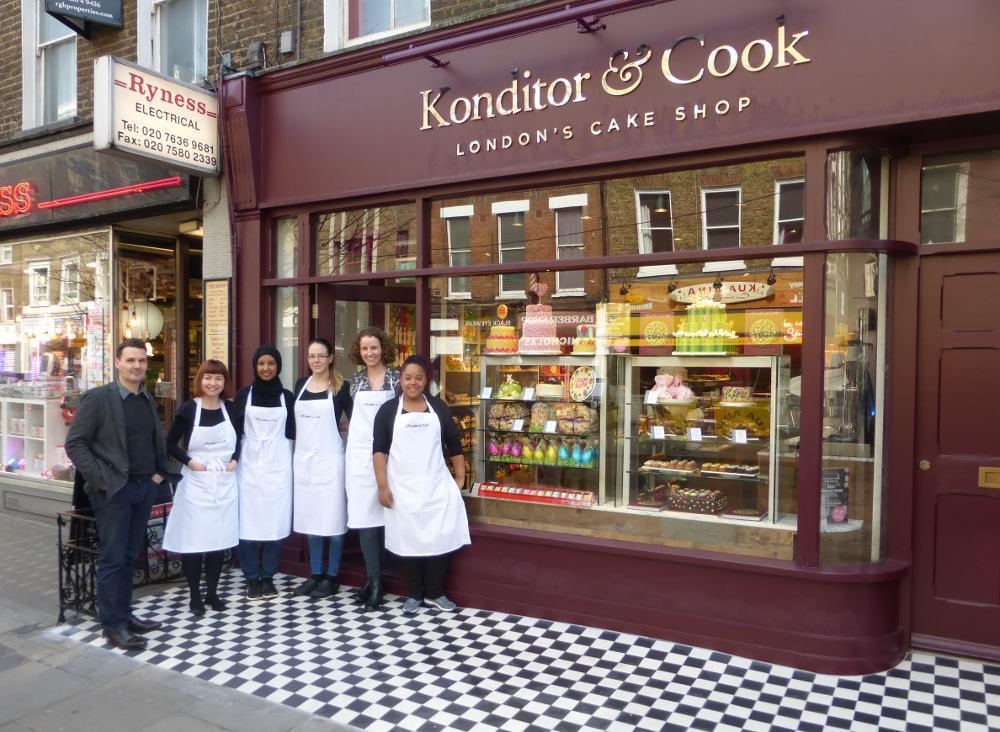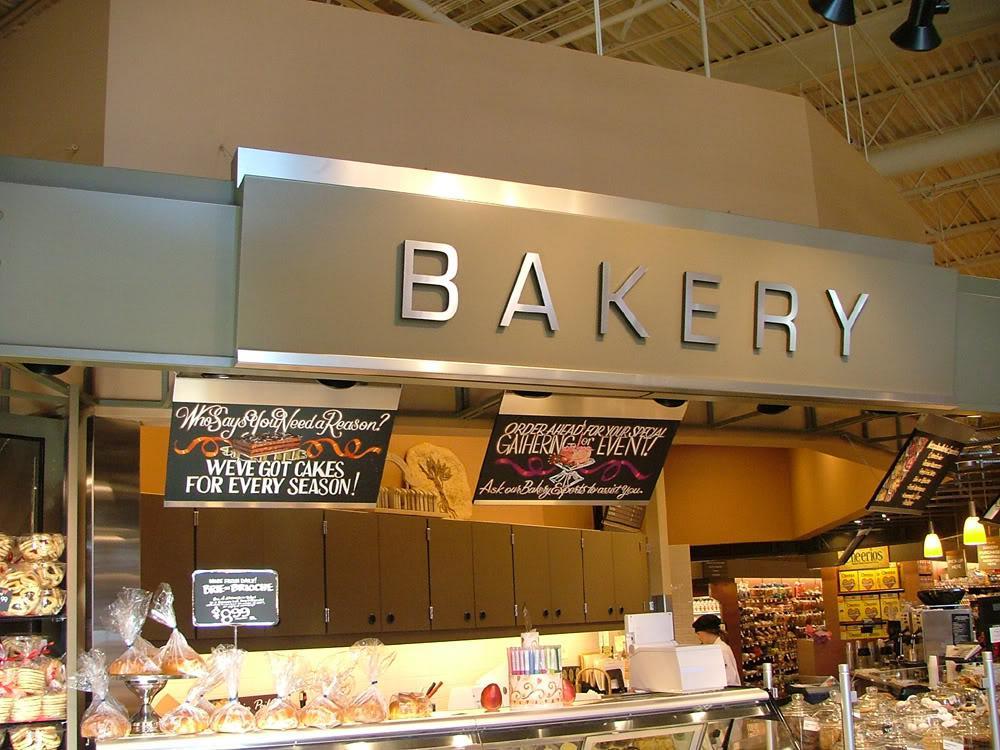The first image is the image on the left, the second image is the image on the right. Considering the images on both sides, is "An image includes a person behind a bakery counter and at least one back-turned person standing in front of the counter." valid? Answer yes or no. No. The first image is the image on the left, the second image is the image on the right. Given the left and right images, does the statement "There are three customers waiting at the bakery counter." hold true? Answer yes or no. No. 